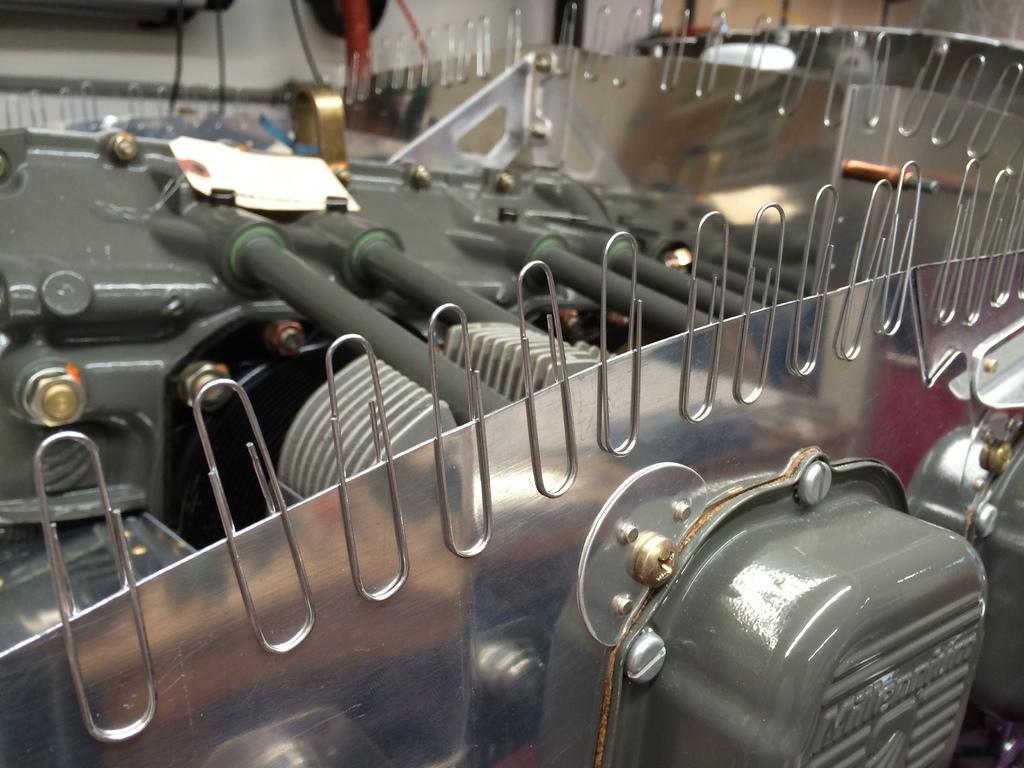Describe this image in one or two sentences. In this image I can see an equipment, a white colour thing in background and I can also see number of of pins. Here I can see something is written. 